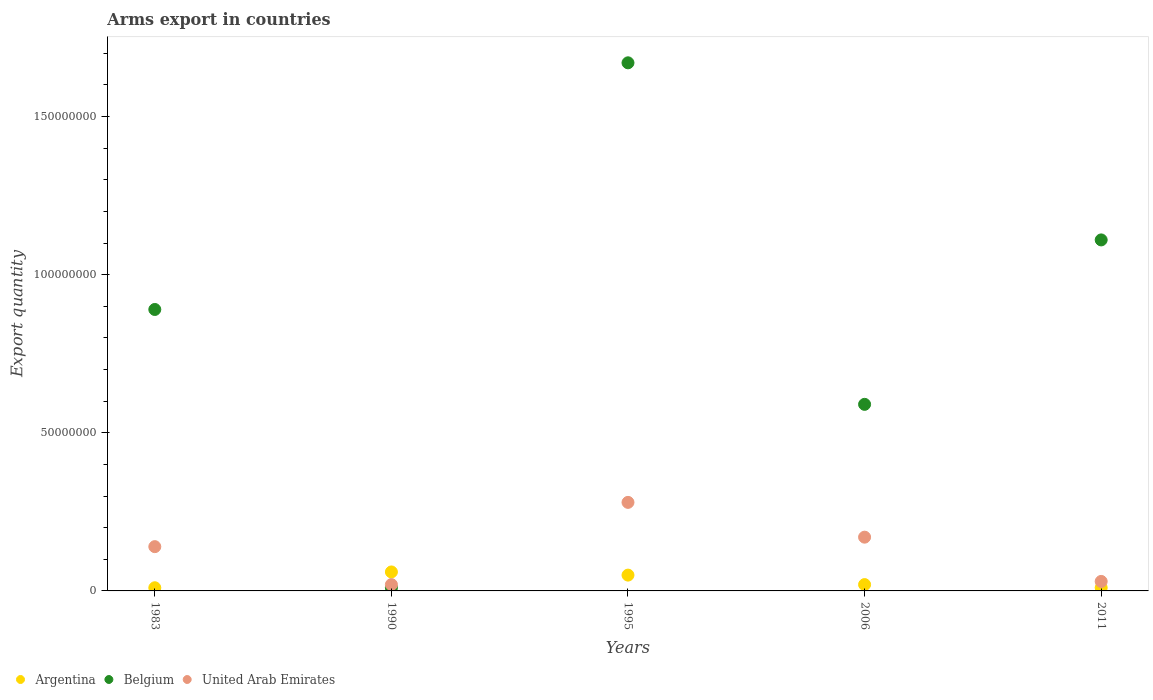What is the total arms export in United Arab Emirates in 1995?
Ensure brevity in your answer.  2.80e+07. Across all years, what is the maximum total arms export in United Arab Emirates?
Your answer should be very brief. 2.80e+07. What is the total total arms export in United Arab Emirates in the graph?
Give a very brief answer. 6.40e+07. What is the difference between the total arms export in Argentina in 1990 and that in 2006?
Your response must be concise. 4.00e+06. What is the average total arms export in Belgium per year?
Offer a very short reply. 8.54e+07. In the year 1990, what is the difference between the total arms export in Belgium and total arms export in Argentina?
Provide a succinct answer. -5.00e+06. In how many years, is the total arms export in Belgium greater than 30000000?
Keep it short and to the point. 4. What is the difference between the highest and the second highest total arms export in United Arab Emirates?
Provide a succinct answer. 1.10e+07. Is it the case that in every year, the sum of the total arms export in Argentina and total arms export in Belgium  is greater than the total arms export in United Arab Emirates?
Your answer should be very brief. Yes. Is the total arms export in Argentina strictly greater than the total arms export in Belgium over the years?
Give a very brief answer. No. Is the total arms export in Belgium strictly less than the total arms export in Argentina over the years?
Offer a very short reply. No. Does the graph contain any zero values?
Offer a terse response. No. Does the graph contain grids?
Ensure brevity in your answer.  No. How are the legend labels stacked?
Offer a very short reply. Horizontal. What is the title of the graph?
Offer a very short reply. Arms export in countries. What is the label or title of the X-axis?
Give a very brief answer. Years. What is the label or title of the Y-axis?
Give a very brief answer. Export quantity. What is the Export quantity of Belgium in 1983?
Your answer should be compact. 8.90e+07. What is the Export quantity of United Arab Emirates in 1983?
Your answer should be very brief. 1.40e+07. What is the Export quantity in Argentina in 1990?
Offer a very short reply. 6.00e+06. What is the Export quantity of Belgium in 1990?
Make the answer very short. 1.00e+06. What is the Export quantity in United Arab Emirates in 1990?
Give a very brief answer. 2.00e+06. What is the Export quantity of Belgium in 1995?
Your answer should be very brief. 1.67e+08. What is the Export quantity in United Arab Emirates in 1995?
Offer a very short reply. 2.80e+07. What is the Export quantity of Belgium in 2006?
Offer a terse response. 5.90e+07. What is the Export quantity in United Arab Emirates in 2006?
Give a very brief answer. 1.70e+07. What is the Export quantity of Argentina in 2011?
Ensure brevity in your answer.  1.00e+06. What is the Export quantity in Belgium in 2011?
Your response must be concise. 1.11e+08. Across all years, what is the maximum Export quantity of Argentina?
Provide a succinct answer. 6.00e+06. Across all years, what is the maximum Export quantity of Belgium?
Offer a very short reply. 1.67e+08. Across all years, what is the maximum Export quantity of United Arab Emirates?
Your response must be concise. 2.80e+07. Across all years, what is the minimum Export quantity in Argentina?
Offer a very short reply. 1.00e+06. Across all years, what is the minimum Export quantity of United Arab Emirates?
Your answer should be very brief. 2.00e+06. What is the total Export quantity of Argentina in the graph?
Provide a short and direct response. 1.50e+07. What is the total Export quantity in Belgium in the graph?
Your answer should be very brief. 4.27e+08. What is the total Export quantity in United Arab Emirates in the graph?
Give a very brief answer. 6.40e+07. What is the difference between the Export quantity of Argentina in 1983 and that in 1990?
Give a very brief answer. -5.00e+06. What is the difference between the Export quantity of Belgium in 1983 and that in 1990?
Ensure brevity in your answer.  8.80e+07. What is the difference between the Export quantity of Belgium in 1983 and that in 1995?
Your response must be concise. -7.80e+07. What is the difference between the Export quantity of United Arab Emirates in 1983 and that in 1995?
Give a very brief answer. -1.40e+07. What is the difference between the Export quantity in Argentina in 1983 and that in 2006?
Offer a very short reply. -1.00e+06. What is the difference between the Export quantity in Belgium in 1983 and that in 2006?
Your answer should be very brief. 3.00e+07. What is the difference between the Export quantity of United Arab Emirates in 1983 and that in 2006?
Provide a short and direct response. -3.00e+06. What is the difference between the Export quantity in Argentina in 1983 and that in 2011?
Provide a succinct answer. 0. What is the difference between the Export quantity in Belgium in 1983 and that in 2011?
Your answer should be very brief. -2.20e+07. What is the difference between the Export quantity in United Arab Emirates in 1983 and that in 2011?
Provide a short and direct response. 1.10e+07. What is the difference between the Export quantity of Belgium in 1990 and that in 1995?
Provide a succinct answer. -1.66e+08. What is the difference between the Export quantity in United Arab Emirates in 1990 and that in 1995?
Ensure brevity in your answer.  -2.60e+07. What is the difference between the Export quantity in Belgium in 1990 and that in 2006?
Offer a terse response. -5.80e+07. What is the difference between the Export quantity in United Arab Emirates in 1990 and that in 2006?
Your answer should be very brief. -1.50e+07. What is the difference between the Export quantity in Belgium in 1990 and that in 2011?
Give a very brief answer. -1.10e+08. What is the difference between the Export quantity in Belgium in 1995 and that in 2006?
Provide a succinct answer. 1.08e+08. What is the difference between the Export quantity in United Arab Emirates in 1995 and that in 2006?
Keep it short and to the point. 1.10e+07. What is the difference between the Export quantity in Argentina in 1995 and that in 2011?
Your answer should be very brief. 4.00e+06. What is the difference between the Export quantity of Belgium in 1995 and that in 2011?
Offer a very short reply. 5.60e+07. What is the difference between the Export quantity in United Arab Emirates in 1995 and that in 2011?
Provide a short and direct response. 2.50e+07. What is the difference between the Export quantity of Belgium in 2006 and that in 2011?
Your answer should be compact. -5.20e+07. What is the difference between the Export quantity of United Arab Emirates in 2006 and that in 2011?
Keep it short and to the point. 1.40e+07. What is the difference between the Export quantity of Argentina in 1983 and the Export quantity of United Arab Emirates in 1990?
Offer a very short reply. -1.00e+06. What is the difference between the Export quantity of Belgium in 1983 and the Export quantity of United Arab Emirates in 1990?
Provide a succinct answer. 8.70e+07. What is the difference between the Export quantity in Argentina in 1983 and the Export quantity in Belgium in 1995?
Your response must be concise. -1.66e+08. What is the difference between the Export quantity in Argentina in 1983 and the Export quantity in United Arab Emirates in 1995?
Ensure brevity in your answer.  -2.70e+07. What is the difference between the Export quantity in Belgium in 1983 and the Export quantity in United Arab Emirates in 1995?
Keep it short and to the point. 6.10e+07. What is the difference between the Export quantity in Argentina in 1983 and the Export quantity in Belgium in 2006?
Your answer should be very brief. -5.80e+07. What is the difference between the Export quantity of Argentina in 1983 and the Export quantity of United Arab Emirates in 2006?
Provide a succinct answer. -1.60e+07. What is the difference between the Export quantity of Belgium in 1983 and the Export quantity of United Arab Emirates in 2006?
Your answer should be compact. 7.20e+07. What is the difference between the Export quantity of Argentina in 1983 and the Export quantity of Belgium in 2011?
Your answer should be very brief. -1.10e+08. What is the difference between the Export quantity of Argentina in 1983 and the Export quantity of United Arab Emirates in 2011?
Your answer should be compact. -2.00e+06. What is the difference between the Export quantity of Belgium in 1983 and the Export quantity of United Arab Emirates in 2011?
Offer a very short reply. 8.60e+07. What is the difference between the Export quantity in Argentina in 1990 and the Export quantity in Belgium in 1995?
Make the answer very short. -1.61e+08. What is the difference between the Export quantity of Argentina in 1990 and the Export quantity of United Arab Emirates in 1995?
Offer a very short reply. -2.20e+07. What is the difference between the Export quantity in Belgium in 1990 and the Export quantity in United Arab Emirates in 1995?
Your answer should be very brief. -2.70e+07. What is the difference between the Export quantity of Argentina in 1990 and the Export quantity of Belgium in 2006?
Your answer should be very brief. -5.30e+07. What is the difference between the Export quantity of Argentina in 1990 and the Export quantity of United Arab Emirates in 2006?
Offer a very short reply. -1.10e+07. What is the difference between the Export quantity of Belgium in 1990 and the Export quantity of United Arab Emirates in 2006?
Your answer should be very brief. -1.60e+07. What is the difference between the Export quantity in Argentina in 1990 and the Export quantity in Belgium in 2011?
Offer a terse response. -1.05e+08. What is the difference between the Export quantity of Argentina in 1990 and the Export quantity of United Arab Emirates in 2011?
Make the answer very short. 3.00e+06. What is the difference between the Export quantity in Argentina in 1995 and the Export quantity in Belgium in 2006?
Your answer should be compact. -5.40e+07. What is the difference between the Export quantity of Argentina in 1995 and the Export quantity of United Arab Emirates in 2006?
Offer a very short reply. -1.20e+07. What is the difference between the Export quantity in Belgium in 1995 and the Export quantity in United Arab Emirates in 2006?
Your answer should be compact. 1.50e+08. What is the difference between the Export quantity of Argentina in 1995 and the Export quantity of Belgium in 2011?
Provide a short and direct response. -1.06e+08. What is the difference between the Export quantity in Belgium in 1995 and the Export quantity in United Arab Emirates in 2011?
Keep it short and to the point. 1.64e+08. What is the difference between the Export quantity of Argentina in 2006 and the Export quantity of Belgium in 2011?
Give a very brief answer. -1.09e+08. What is the difference between the Export quantity of Argentina in 2006 and the Export quantity of United Arab Emirates in 2011?
Offer a terse response. -1.00e+06. What is the difference between the Export quantity of Belgium in 2006 and the Export quantity of United Arab Emirates in 2011?
Your answer should be very brief. 5.60e+07. What is the average Export quantity of Belgium per year?
Ensure brevity in your answer.  8.54e+07. What is the average Export quantity in United Arab Emirates per year?
Offer a very short reply. 1.28e+07. In the year 1983, what is the difference between the Export quantity of Argentina and Export quantity of Belgium?
Offer a very short reply. -8.80e+07. In the year 1983, what is the difference between the Export quantity of Argentina and Export quantity of United Arab Emirates?
Keep it short and to the point. -1.30e+07. In the year 1983, what is the difference between the Export quantity of Belgium and Export quantity of United Arab Emirates?
Offer a very short reply. 7.50e+07. In the year 1990, what is the difference between the Export quantity of Argentina and Export quantity of Belgium?
Provide a short and direct response. 5.00e+06. In the year 1990, what is the difference between the Export quantity of Belgium and Export quantity of United Arab Emirates?
Provide a succinct answer. -1.00e+06. In the year 1995, what is the difference between the Export quantity in Argentina and Export quantity in Belgium?
Make the answer very short. -1.62e+08. In the year 1995, what is the difference between the Export quantity of Argentina and Export quantity of United Arab Emirates?
Your response must be concise. -2.30e+07. In the year 1995, what is the difference between the Export quantity of Belgium and Export quantity of United Arab Emirates?
Your answer should be compact. 1.39e+08. In the year 2006, what is the difference between the Export quantity of Argentina and Export quantity of Belgium?
Give a very brief answer. -5.70e+07. In the year 2006, what is the difference between the Export quantity of Argentina and Export quantity of United Arab Emirates?
Ensure brevity in your answer.  -1.50e+07. In the year 2006, what is the difference between the Export quantity in Belgium and Export quantity in United Arab Emirates?
Give a very brief answer. 4.20e+07. In the year 2011, what is the difference between the Export quantity in Argentina and Export quantity in Belgium?
Offer a terse response. -1.10e+08. In the year 2011, what is the difference between the Export quantity of Belgium and Export quantity of United Arab Emirates?
Keep it short and to the point. 1.08e+08. What is the ratio of the Export quantity in Belgium in 1983 to that in 1990?
Offer a terse response. 89. What is the ratio of the Export quantity in Belgium in 1983 to that in 1995?
Offer a terse response. 0.53. What is the ratio of the Export quantity of United Arab Emirates in 1983 to that in 1995?
Your response must be concise. 0.5. What is the ratio of the Export quantity of Belgium in 1983 to that in 2006?
Provide a short and direct response. 1.51. What is the ratio of the Export quantity in United Arab Emirates in 1983 to that in 2006?
Make the answer very short. 0.82. What is the ratio of the Export quantity of Argentina in 1983 to that in 2011?
Ensure brevity in your answer.  1. What is the ratio of the Export quantity in Belgium in 1983 to that in 2011?
Provide a succinct answer. 0.8. What is the ratio of the Export quantity of United Arab Emirates in 1983 to that in 2011?
Offer a terse response. 4.67. What is the ratio of the Export quantity in Belgium in 1990 to that in 1995?
Your answer should be very brief. 0.01. What is the ratio of the Export quantity of United Arab Emirates in 1990 to that in 1995?
Your response must be concise. 0.07. What is the ratio of the Export quantity in Belgium in 1990 to that in 2006?
Offer a terse response. 0.02. What is the ratio of the Export quantity in United Arab Emirates in 1990 to that in 2006?
Provide a short and direct response. 0.12. What is the ratio of the Export quantity in Belgium in 1990 to that in 2011?
Offer a very short reply. 0.01. What is the ratio of the Export quantity in United Arab Emirates in 1990 to that in 2011?
Provide a succinct answer. 0.67. What is the ratio of the Export quantity in Argentina in 1995 to that in 2006?
Keep it short and to the point. 2.5. What is the ratio of the Export quantity in Belgium in 1995 to that in 2006?
Ensure brevity in your answer.  2.83. What is the ratio of the Export quantity of United Arab Emirates in 1995 to that in 2006?
Offer a terse response. 1.65. What is the ratio of the Export quantity of Argentina in 1995 to that in 2011?
Your response must be concise. 5. What is the ratio of the Export quantity of Belgium in 1995 to that in 2011?
Give a very brief answer. 1.5. What is the ratio of the Export quantity in United Arab Emirates in 1995 to that in 2011?
Offer a terse response. 9.33. What is the ratio of the Export quantity in Belgium in 2006 to that in 2011?
Make the answer very short. 0.53. What is the ratio of the Export quantity of United Arab Emirates in 2006 to that in 2011?
Offer a terse response. 5.67. What is the difference between the highest and the second highest Export quantity of Argentina?
Keep it short and to the point. 1.00e+06. What is the difference between the highest and the second highest Export quantity in Belgium?
Your answer should be compact. 5.60e+07. What is the difference between the highest and the second highest Export quantity of United Arab Emirates?
Your answer should be very brief. 1.10e+07. What is the difference between the highest and the lowest Export quantity in Argentina?
Your answer should be very brief. 5.00e+06. What is the difference between the highest and the lowest Export quantity in Belgium?
Provide a succinct answer. 1.66e+08. What is the difference between the highest and the lowest Export quantity of United Arab Emirates?
Provide a succinct answer. 2.60e+07. 